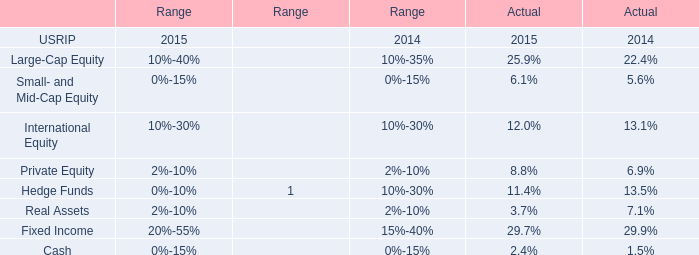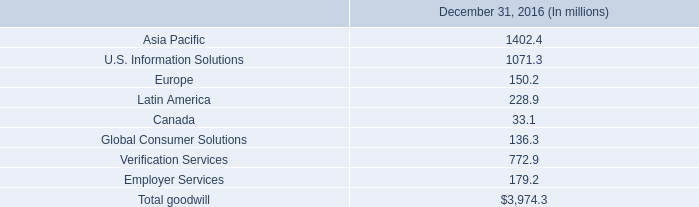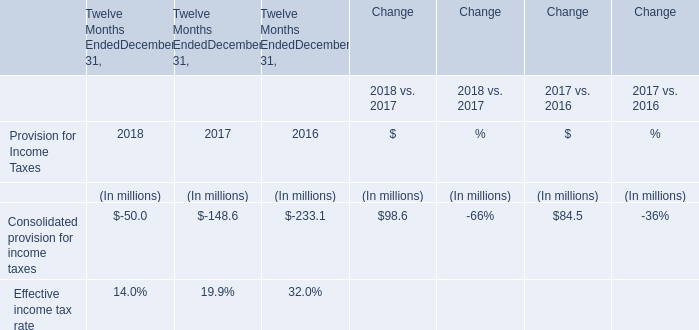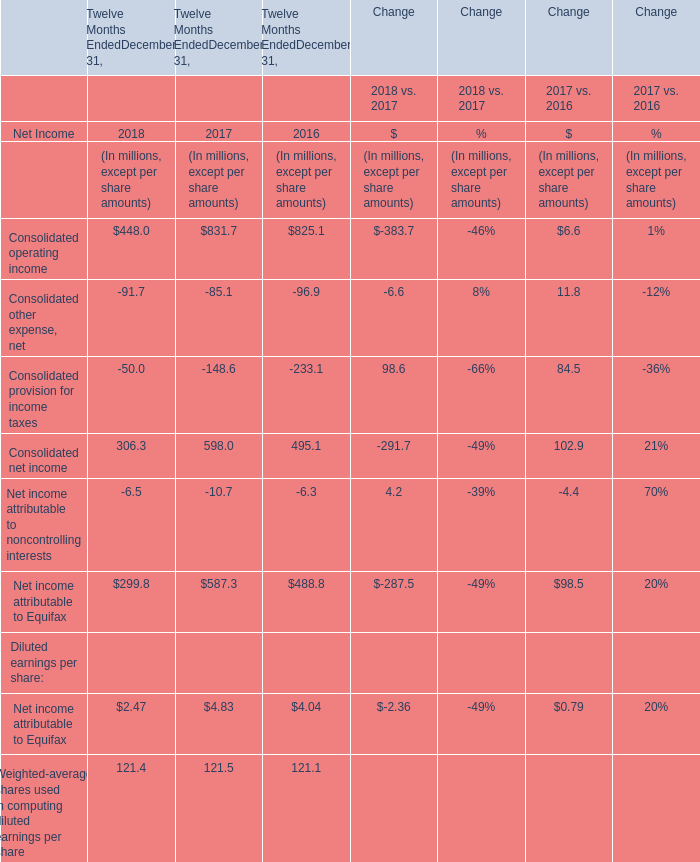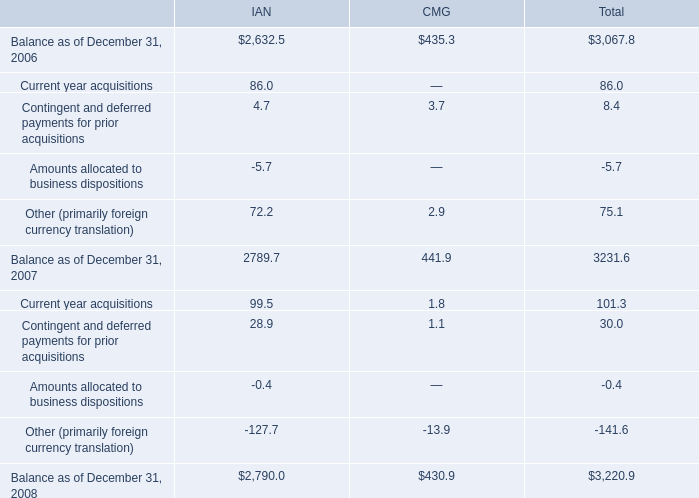What was the average value of the Consolidated net income in the years where Consolidated operating income positive? (in million) 
Computations: (((306.3 + 598.0) + 495.1) / 3)
Answer: 466.46667. 